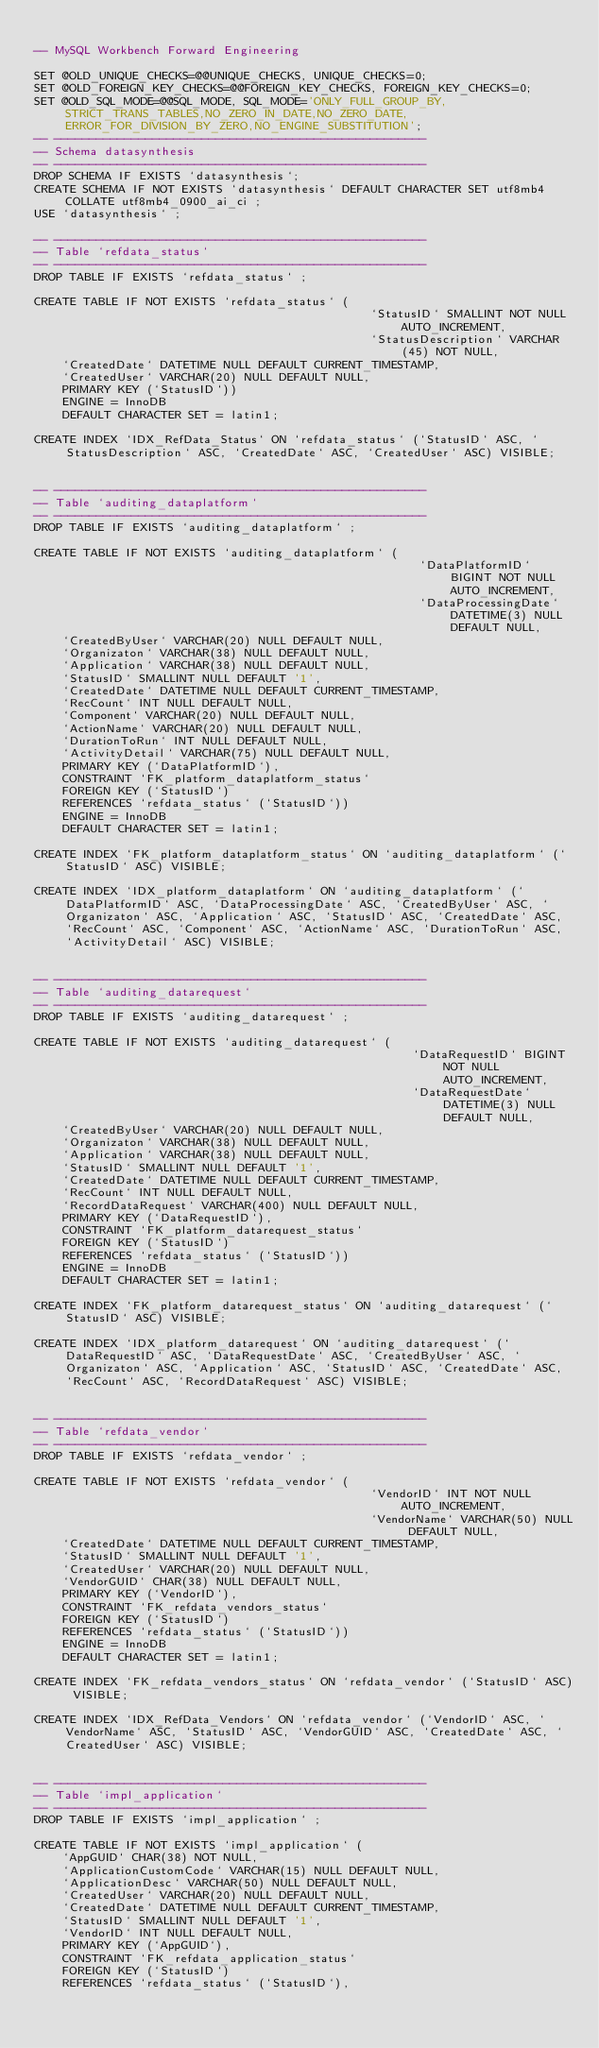Convert code to text. <code><loc_0><loc_0><loc_500><loc_500><_SQL_>
-- MySQL Workbench Forward Engineering

SET @OLD_UNIQUE_CHECKS=@@UNIQUE_CHECKS, UNIQUE_CHECKS=0;
SET @OLD_FOREIGN_KEY_CHECKS=@@FOREIGN_KEY_CHECKS, FOREIGN_KEY_CHECKS=0;
SET @OLD_SQL_MODE=@@SQL_MODE, SQL_MODE='ONLY_FULL_GROUP_BY,STRICT_TRANS_TABLES,NO_ZERO_IN_DATE,NO_ZERO_DATE,ERROR_FOR_DIVISION_BY_ZERO,NO_ENGINE_SUBSTITUTION';
-- -----------------------------------------------------
-- Schema datasynthesis
-- -----------------------------------------------------
DROP SCHEMA IF EXISTS `datasynthesis`;
CREATE SCHEMA IF NOT EXISTS `datasynthesis` DEFAULT CHARACTER SET utf8mb4 COLLATE utf8mb4_0900_ai_ci ;
USE `datasynthesis` ;

-- -----------------------------------------------------
-- Table `refdata_status`
-- -----------------------------------------------------
DROP TABLE IF EXISTS `refdata_status` ;

CREATE TABLE IF NOT EXISTS `refdata_status` (
                                                `StatusID` SMALLINT NOT NULL AUTO_INCREMENT,
                                                `StatusDescription` VARCHAR(45) NOT NULL,
    `CreatedDate` DATETIME NULL DEFAULT CURRENT_TIMESTAMP,
    `CreatedUser` VARCHAR(20) NULL DEFAULT NULL,
    PRIMARY KEY (`StatusID`))
    ENGINE = InnoDB
    DEFAULT CHARACTER SET = latin1;

CREATE INDEX `IDX_RefData_Status` ON `refdata_status` (`StatusID` ASC, `StatusDescription` ASC, `CreatedDate` ASC, `CreatedUser` ASC) VISIBLE;


-- -----------------------------------------------------
-- Table `auditing_dataplatform`
-- -----------------------------------------------------
DROP TABLE IF EXISTS `auditing_dataplatform` ;

CREATE TABLE IF NOT EXISTS `auditing_dataplatform` (
                                                       `DataPlatformID` BIGINT NOT NULL AUTO_INCREMENT,
                                                       `DataProcessingDate` DATETIME(3) NULL DEFAULT NULL,
    `CreatedByUser` VARCHAR(20) NULL DEFAULT NULL,
    `Organizaton` VARCHAR(38) NULL DEFAULT NULL,
    `Application` VARCHAR(38) NULL DEFAULT NULL,
    `StatusID` SMALLINT NULL DEFAULT '1',
    `CreatedDate` DATETIME NULL DEFAULT CURRENT_TIMESTAMP,
    `RecCount` INT NULL DEFAULT NULL,
    `Component` VARCHAR(20) NULL DEFAULT NULL,
    `ActionName` VARCHAR(20) NULL DEFAULT NULL,
    `DurationToRun` INT NULL DEFAULT NULL,
    `ActivityDetail` VARCHAR(75) NULL DEFAULT NULL,
    PRIMARY KEY (`DataPlatformID`),
    CONSTRAINT `FK_platform_dataplatform_status`
    FOREIGN KEY (`StatusID`)
    REFERENCES `refdata_status` (`StatusID`))
    ENGINE = InnoDB
    DEFAULT CHARACTER SET = latin1;

CREATE INDEX `FK_platform_dataplatform_status` ON `auditing_dataplatform` (`StatusID` ASC) VISIBLE;

CREATE INDEX `IDX_platform_dataplatform` ON `auditing_dataplatform` (`DataPlatformID` ASC, `DataProcessingDate` ASC, `CreatedByUser` ASC, `Organizaton` ASC, `Application` ASC, `StatusID` ASC, `CreatedDate` ASC, `RecCount` ASC, `Component` ASC, `ActionName` ASC, `DurationToRun` ASC, `ActivityDetail` ASC) VISIBLE;


-- -----------------------------------------------------
-- Table `auditing_datarequest`
-- -----------------------------------------------------
DROP TABLE IF EXISTS `auditing_datarequest` ;

CREATE TABLE IF NOT EXISTS `auditing_datarequest` (
                                                      `DataRequestID` BIGINT NOT NULL AUTO_INCREMENT,
                                                      `DataRequestDate` DATETIME(3) NULL DEFAULT NULL,
    `CreatedByUser` VARCHAR(20) NULL DEFAULT NULL,
    `Organizaton` VARCHAR(38) NULL DEFAULT NULL,
    `Application` VARCHAR(38) NULL DEFAULT NULL,
    `StatusID` SMALLINT NULL DEFAULT '1',
    `CreatedDate` DATETIME NULL DEFAULT CURRENT_TIMESTAMP,
    `RecCount` INT NULL DEFAULT NULL,
    `RecordDataRequest` VARCHAR(400) NULL DEFAULT NULL,
    PRIMARY KEY (`DataRequestID`),
    CONSTRAINT `FK_platform_datarequest_status`
    FOREIGN KEY (`StatusID`)
    REFERENCES `refdata_status` (`StatusID`))
    ENGINE = InnoDB
    DEFAULT CHARACTER SET = latin1;

CREATE INDEX `FK_platform_datarequest_status` ON `auditing_datarequest` (`StatusID` ASC) VISIBLE;

CREATE INDEX `IDX_platform_datarequest` ON `auditing_datarequest` (`DataRequestID` ASC, `DataRequestDate` ASC, `CreatedByUser` ASC, `Organizaton` ASC, `Application` ASC, `StatusID` ASC, `CreatedDate` ASC, `RecCount` ASC, `RecordDataRequest` ASC) VISIBLE;


-- -----------------------------------------------------
-- Table `refdata_vendor`
-- -----------------------------------------------------
DROP TABLE IF EXISTS `refdata_vendor` ;

CREATE TABLE IF NOT EXISTS `refdata_vendor` (
                                                `VendorID` INT NOT NULL AUTO_INCREMENT,
                                                `VendorName` VARCHAR(50) NULL DEFAULT NULL,
    `CreatedDate` DATETIME NULL DEFAULT CURRENT_TIMESTAMP,
    `StatusID` SMALLINT NULL DEFAULT '1',
    `CreatedUser` VARCHAR(20) NULL DEFAULT NULL,
    `VendorGUID` CHAR(38) NULL DEFAULT NULL,
    PRIMARY KEY (`VendorID`),
    CONSTRAINT `FK_refdata_vendors_status`
    FOREIGN KEY (`StatusID`)
    REFERENCES `refdata_status` (`StatusID`))
    ENGINE = InnoDB
    DEFAULT CHARACTER SET = latin1;

CREATE INDEX `FK_refdata_vendors_status` ON `refdata_vendor` (`StatusID` ASC) VISIBLE;

CREATE INDEX `IDX_RefData_Vendors` ON `refdata_vendor` (`VendorID` ASC, `VendorName` ASC, `StatusID` ASC, `VendorGUID` ASC, `CreatedDate` ASC, `CreatedUser` ASC) VISIBLE;


-- -----------------------------------------------------
-- Table `impl_application`
-- -----------------------------------------------------
DROP TABLE IF EXISTS `impl_application` ;

CREATE TABLE IF NOT EXISTS `impl_application` (
    `AppGUID` CHAR(38) NOT NULL,
    `ApplicationCustomCode` VARCHAR(15) NULL DEFAULT NULL,
    `ApplicationDesc` VARCHAR(50) NULL DEFAULT NULL,
    `CreatedUser` VARCHAR(20) NULL DEFAULT NULL,
    `CreatedDate` DATETIME NULL DEFAULT CURRENT_TIMESTAMP,
    `StatusID` SMALLINT NULL DEFAULT '1',
    `VendorID` INT NULL DEFAULT NULL,
    PRIMARY KEY (`AppGUID`),
    CONSTRAINT `FK_refdata_application_status`
    FOREIGN KEY (`StatusID`)
    REFERENCES `refdata_status` (`StatusID`),</code> 